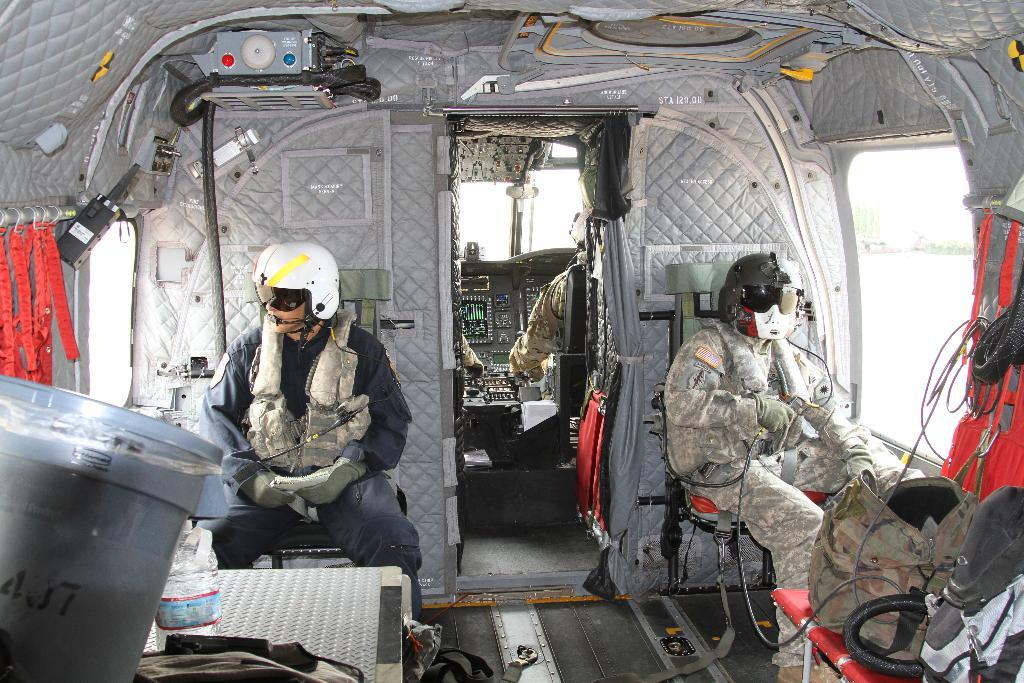What can be seen inside the helicopter in the image? There are people in the helicopter. What objects are on the tables in the image? There are bags on the tables. What is visible outside the helicopter in the image? There is a building outside the helicopter. Is there a bomb visible in the image? No, there is no bomb present in the image. Are there any tents visible in the image? No, there are no tents present in the image. 